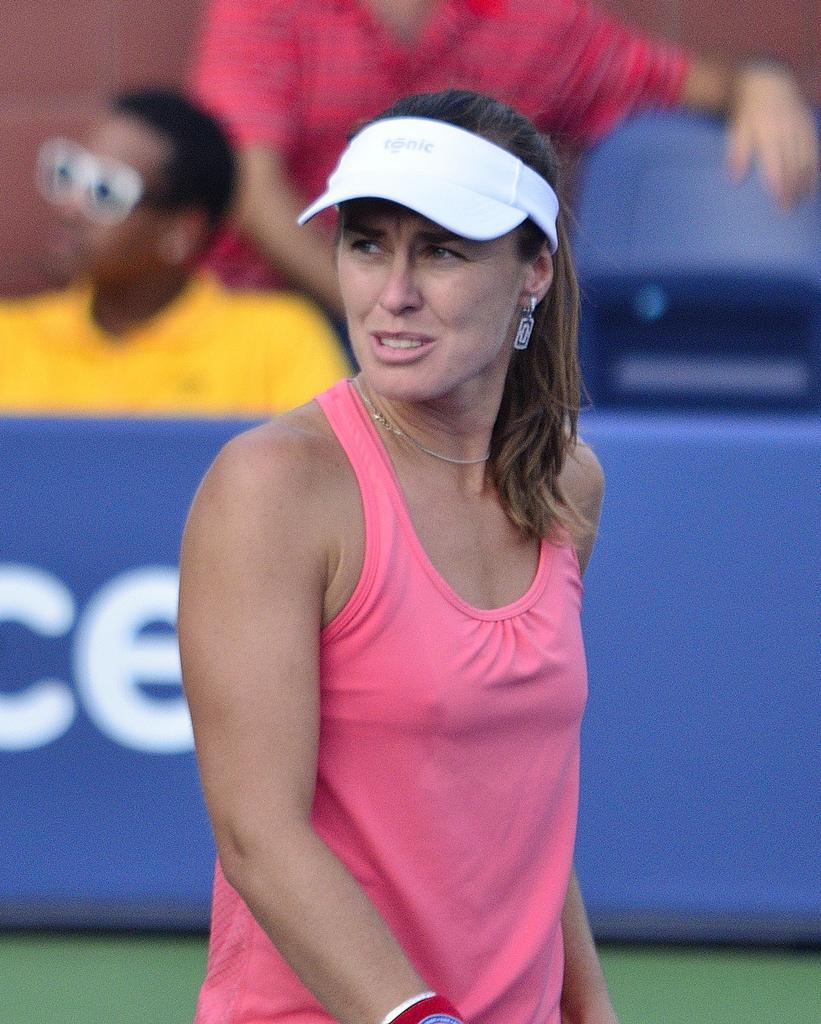Please provide a concise description of this image. In this image we can see a lady wearing cap. In the back there is a wall with something written. Also there are two persons. One person is wearing goggles. And it is looking blur in the background. 